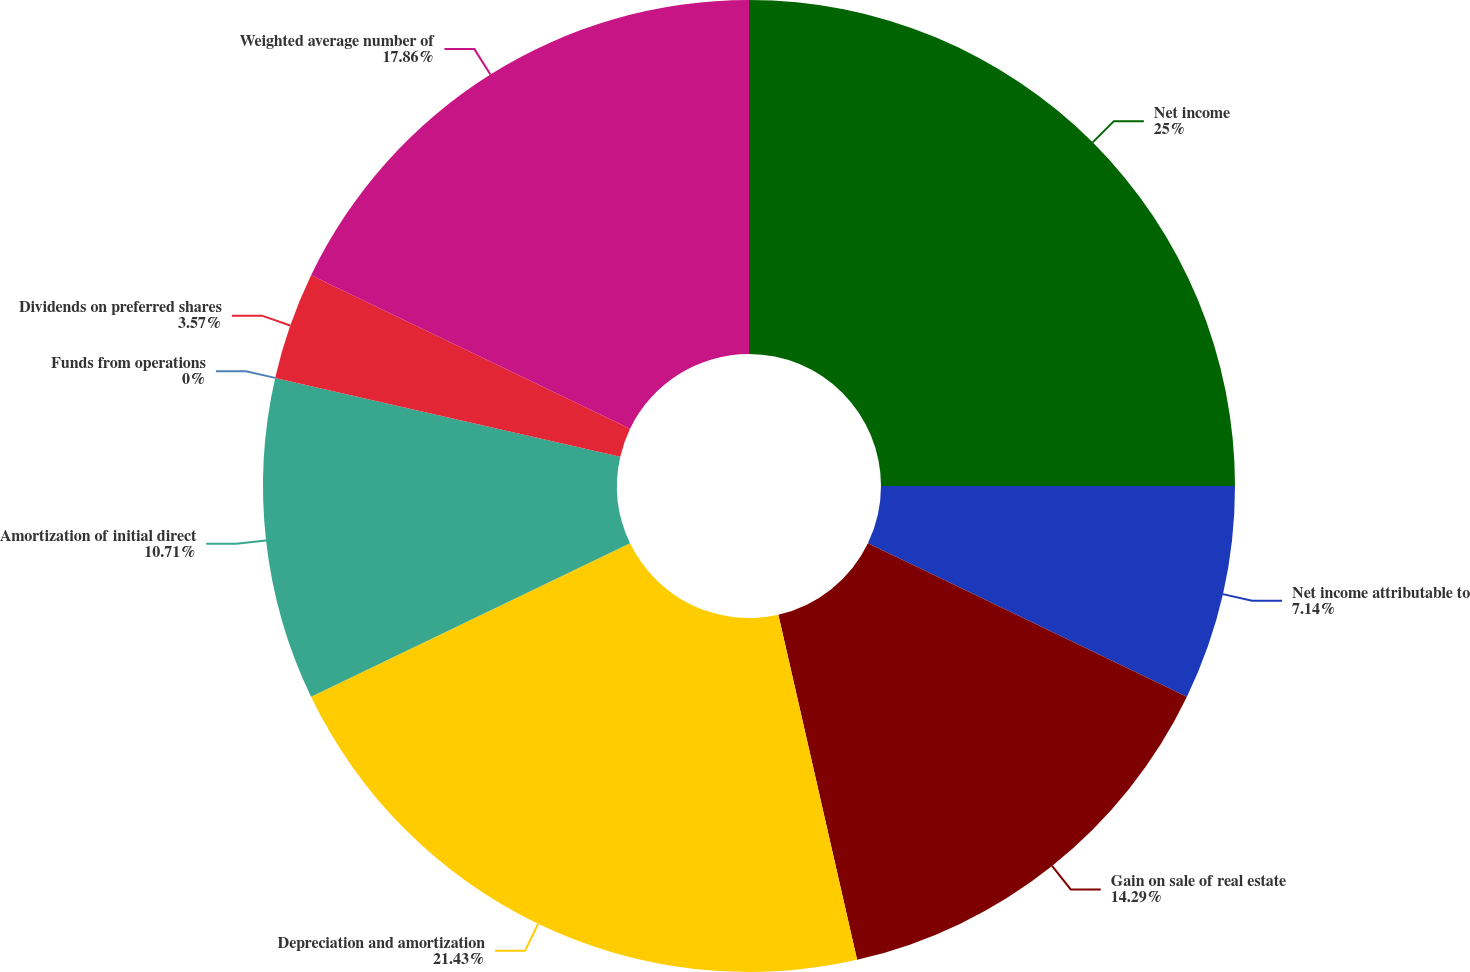<chart> <loc_0><loc_0><loc_500><loc_500><pie_chart><fcel>Net income<fcel>Net income attributable to<fcel>Gain on sale of real estate<fcel>Depreciation and amortization<fcel>Amortization of initial direct<fcel>Funds from operations<fcel>Dividends on preferred shares<fcel>Weighted average number of<nl><fcel>25.0%<fcel>7.14%<fcel>14.29%<fcel>21.43%<fcel>10.71%<fcel>0.0%<fcel>3.57%<fcel>17.86%<nl></chart> 